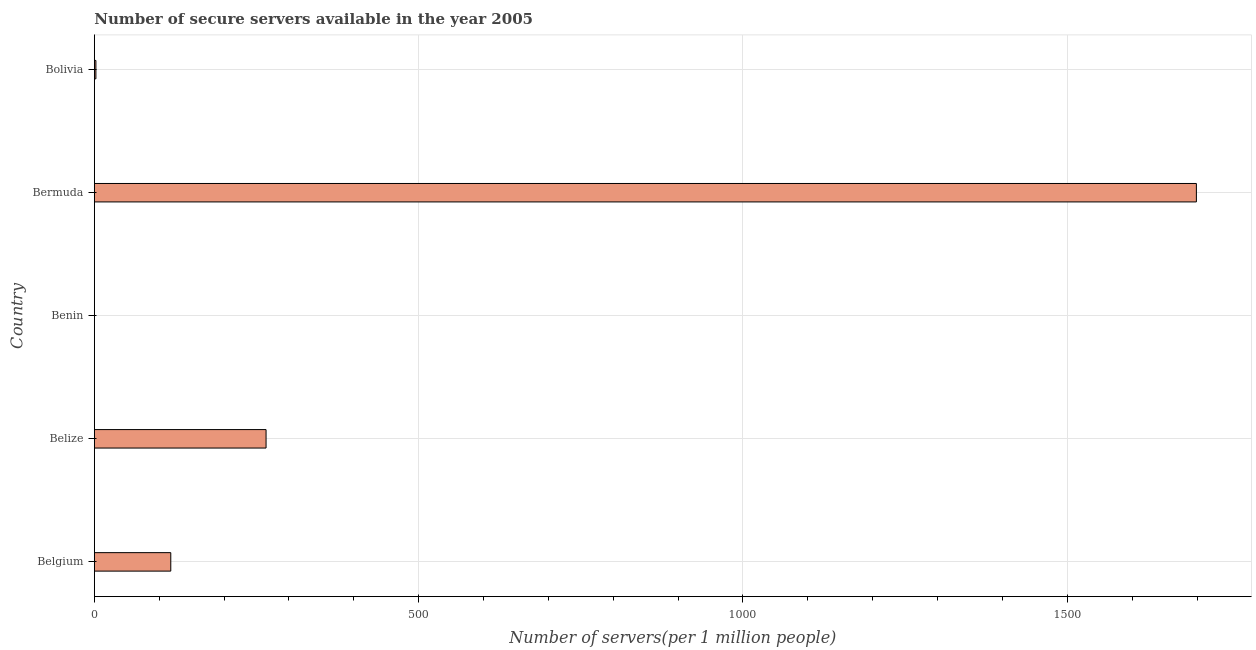Does the graph contain any zero values?
Your answer should be very brief. No. What is the title of the graph?
Ensure brevity in your answer.  Number of secure servers available in the year 2005. What is the label or title of the X-axis?
Provide a short and direct response. Number of servers(per 1 million people). What is the label or title of the Y-axis?
Your answer should be compact. Country. What is the number of secure internet servers in Bermuda?
Your response must be concise. 1699.04. Across all countries, what is the maximum number of secure internet servers?
Your answer should be very brief. 1699.04. Across all countries, what is the minimum number of secure internet servers?
Your answer should be compact. 0.12. In which country was the number of secure internet servers maximum?
Offer a terse response. Bermuda. In which country was the number of secure internet servers minimum?
Your answer should be compact. Benin. What is the sum of the number of secure internet servers?
Give a very brief answer. 2084.19. What is the difference between the number of secure internet servers in Belgium and Belize?
Ensure brevity in your answer.  -146.9. What is the average number of secure internet servers per country?
Your answer should be compact. 416.84. What is the median number of secure internet servers?
Provide a succinct answer. 117.86. What is the difference between the highest and the second highest number of secure internet servers?
Provide a succinct answer. 1434.28. Is the sum of the number of secure internet servers in Belize and Benin greater than the maximum number of secure internet servers across all countries?
Provide a short and direct response. No. What is the difference between the highest and the lowest number of secure internet servers?
Provide a short and direct response. 1698.91. In how many countries, is the number of secure internet servers greater than the average number of secure internet servers taken over all countries?
Your response must be concise. 1. How many bars are there?
Give a very brief answer. 5. Are all the bars in the graph horizontal?
Offer a terse response. Yes. How many countries are there in the graph?
Your answer should be very brief. 5. What is the difference between two consecutive major ticks on the X-axis?
Provide a short and direct response. 500. Are the values on the major ticks of X-axis written in scientific E-notation?
Offer a terse response. No. What is the Number of servers(per 1 million people) in Belgium?
Ensure brevity in your answer.  117.86. What is the Number of servers(per 1 million people) of Belize?
Offer a very short reply. 264.76. What is the Number of servers(per 1 million people) of Benin?
Offer a terse response. 0.12. What is the Number of servers(per 1 million people) in Bermuda?
Your answer should be compact. 1699.04. What is the Number of servers(per 1 million people) in Bolivia?
Ensure brevity in your answer.  2.41. What is the difference between the Number of servers(per 1 million people) in Belgium and Belize?
Offer a very short reply. -146.9. What is the difference between the Number of servers(per 1 million people) in Belgium and Benin?
Make the answer very short. 117.74. What is the difference between the Number of servers(per 1 million people) in Belgium and Bermuda?
Provide a short and direct response. -1581.18. What is the difference between the Number of servers(per 1 million people) in Belgium and Bolivia?
Your answer should be compact. 115.45. What is the difference between the Number of servers(per 1 million people) in Belize and Benin?
Keep it short and to the point. 264.63. What is the difference between the Number of servers(per 1 million people) in Belize and Bermuda?
Your answer should be very brief. -1434.28. What is the difference between the Number of servers(per 1 million people) in Belize and Bolivia?
Provide a succinct answer. 262.35. What is the difference between the Number of servers(per 1 million people) in Benin and Bermuda?
Make the answer very short. -1698.91. What is the difference between the Number of servers(per 1 million people) in Benin and Bolivia?
Offer a terse response. -2.29. What is the difference between the Number of servers(per 1 million people) in Bermuda and Bolivia?
Give a very brief answer. 1696.63. What is the ratio of the Number of servers(per 1 million people) in Belgium to that in Belize?
Offer a terse response. 0.45. What is the ratio of the Number of servers(per 1 million people) in Belgium to that in Benin?
Your response must be concise. 964.37. What is the ratio of the Number of servers(per 1 million people) in Belgium to that in Bermuda?
Your response must be concise. 0.07. What is the ratio of the Number of servers(per 1 million people) in Belgium to that in Bolivia?
Offer a terse response. 48.89. What is the ratio of the Number of servers(per 1 million people) in Belize to that in Benin?
Your answer should be compact. 2166.34. What is the ratio of the Number of servers(per 1 million people) in Belize to that in Bermuda?
Keep it short and to the point. 0.16. What is the ratio of the Number of servers(per 1 million people) in Belize to that in Bolivia?
Make the answer very short. 109.82. What is the ratio of the Number of servers(per 1 million people) in Benin to that in Bolivia?
Provide a short and direct response. 0.05. What is the ratio of the Number of servers(per 1 million people) in Bermuda to that in Bolivia?
Provide a short and direct response. 704.75. 